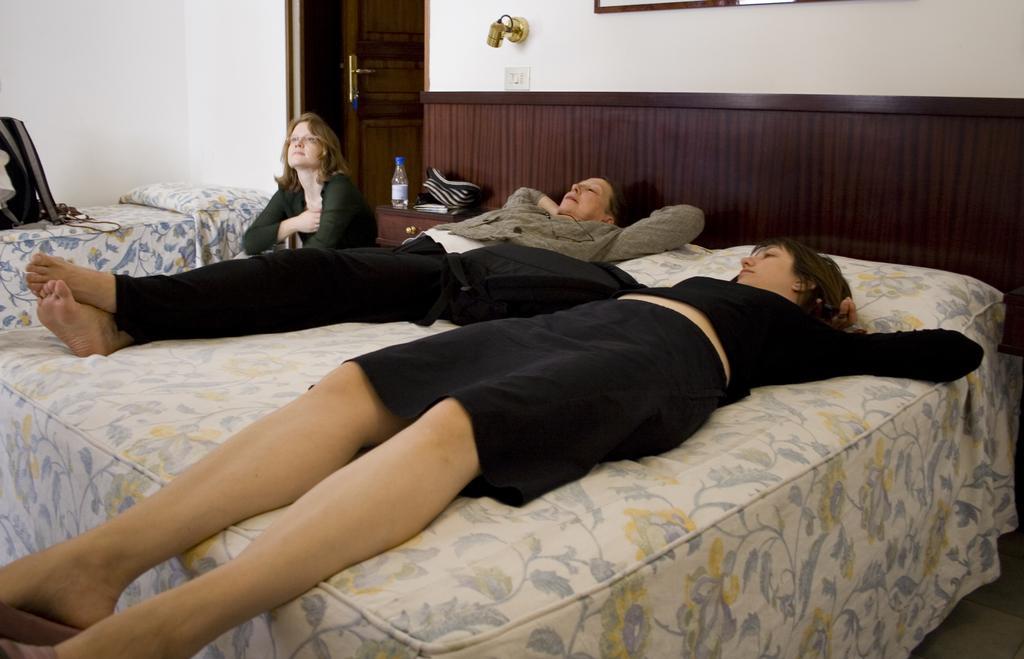Could you give a brief overview of what you see in this image? In this image i can see two women laying on bed at left a woman is sitting at the back ground i can see a bottle on cup board, a wall and a door. 